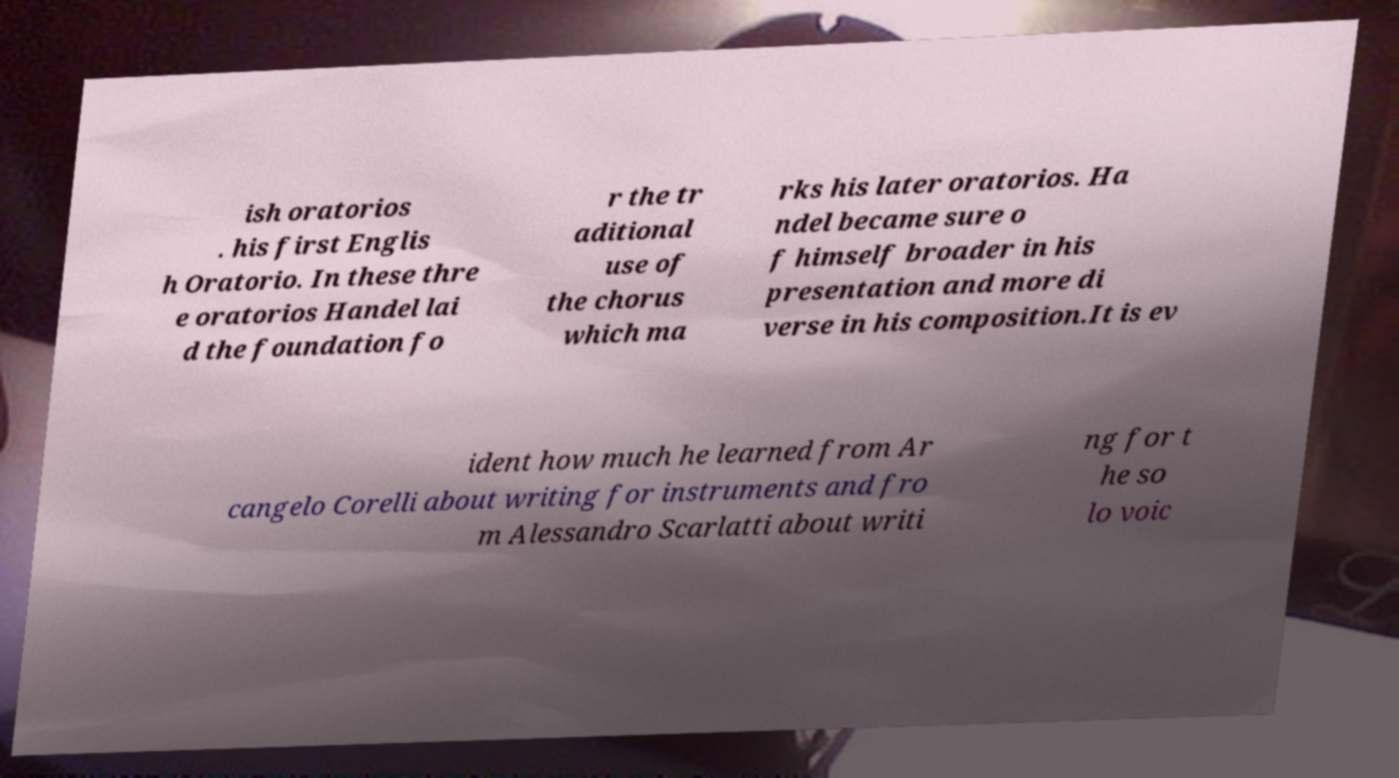Could you extract and type out the text from this image? ish oratorios . his first Englis h Oratorio. In these thre e oratorios Handel lai d the foundation fo r the tr aditional use of the chorus which ma rks his later oratorios. Ha ndel became sure o f himself broader in his presentation and more di verse in his composition.It is ev ident how much he learned from Ar cangelo Corelli about writing for instruments and fro m Alessandro Scarlatti about writi ng for t he so lo voic 